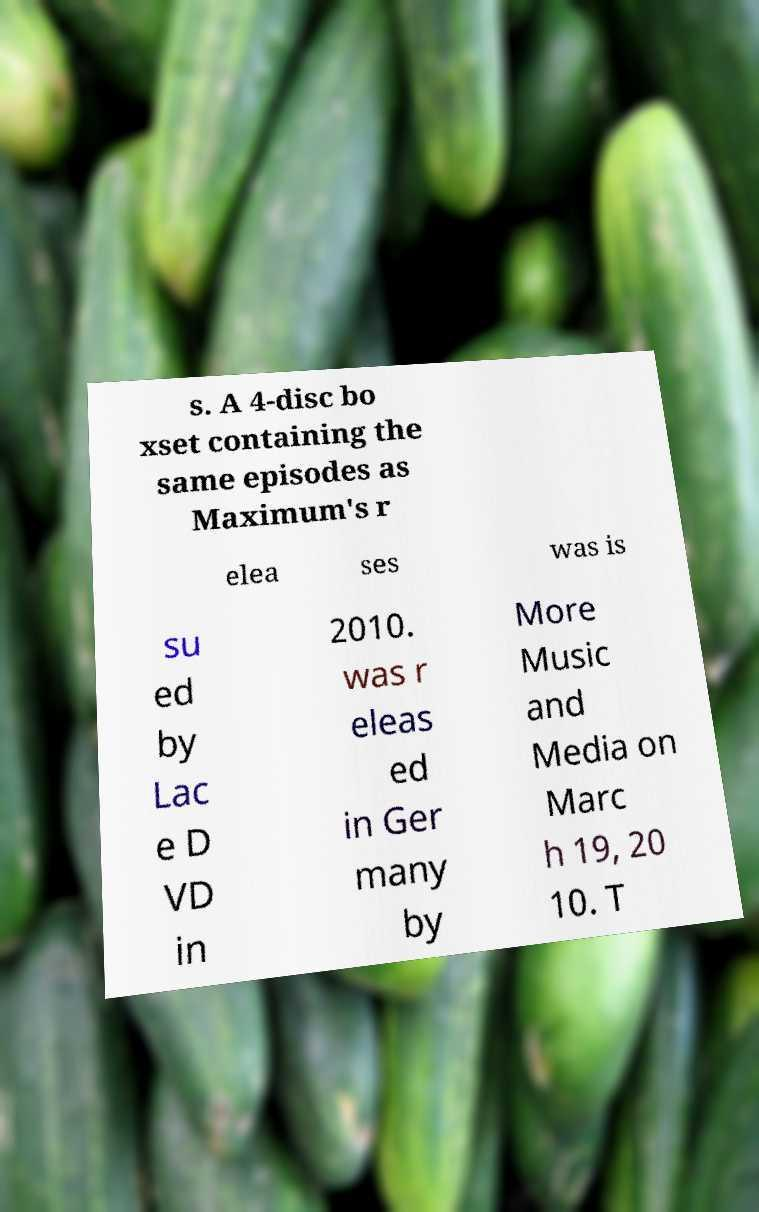Please read and relay the text visible in this image. What does it say? s. A 4-disc bo xset containing the same episodes as Maximum's r elea ses was is su ed by Lac e D VD in 2010. was r eleas ed in Ger many by More Music and Media on Marc h 19, 20 10. T 